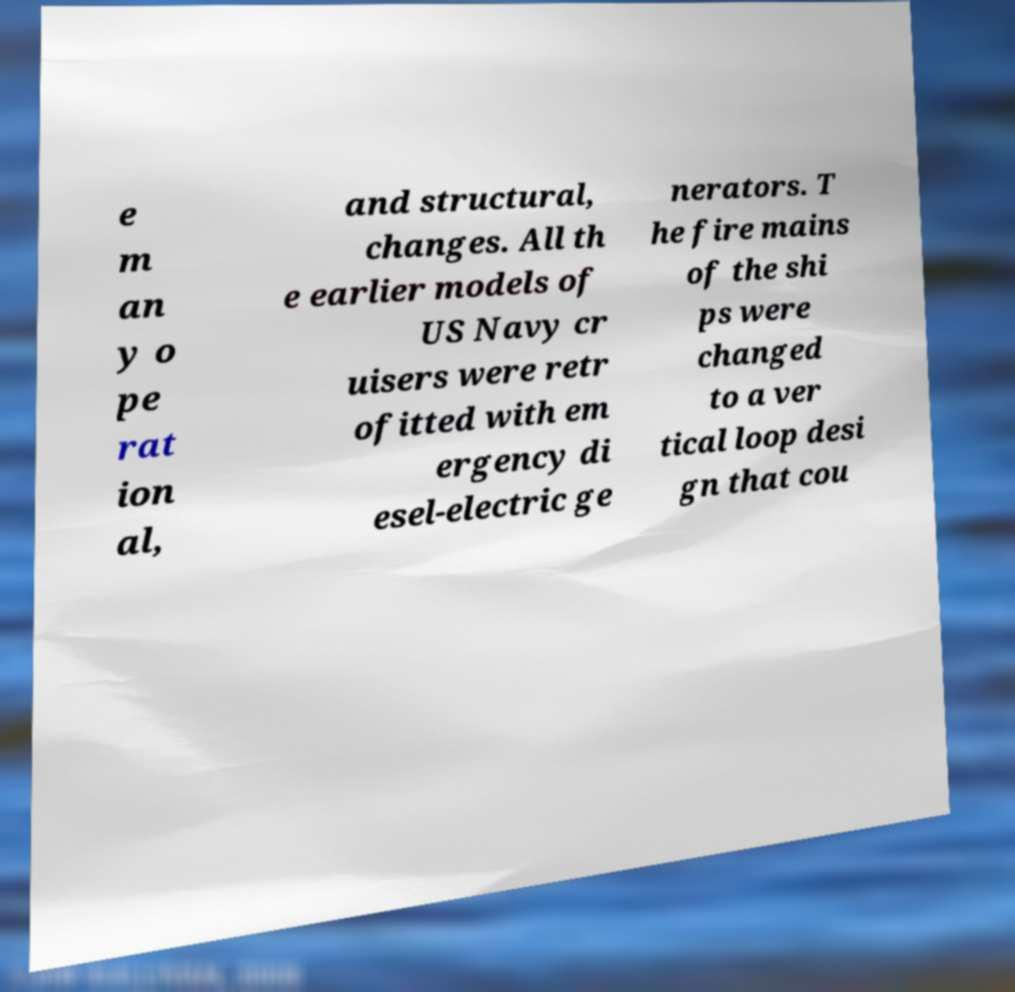Please identify and transcribe the text found in this image. e m an y o pe rat ion al, and structural, changes. All th e earlier models of US Navy cr uisers were retr ofitted with em ergency di esel-electric ge nerators. T he fire mains of the shi ps were changed to a ver tical loop desi gn that cou 